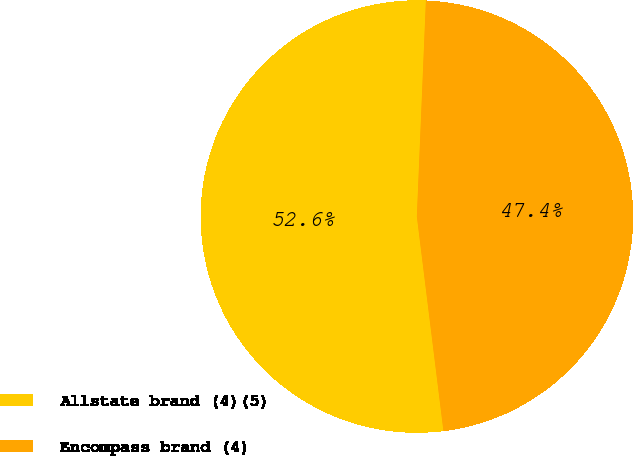<chart> <loc_0><loc_0><loc_500><loc_500><pie_chart><fcel>Allstate brand (4)(5)<fcel>Encompass brand (4)<nl><fcel>52.63%<fcel>47.37%<nl></chart> 